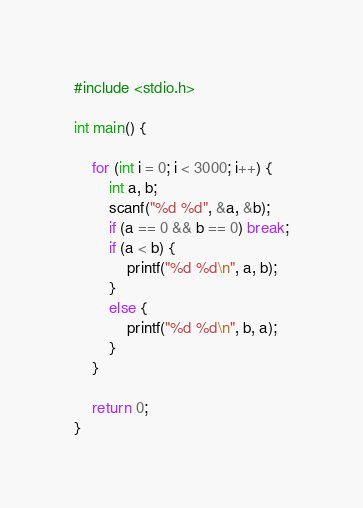Convert code to text. <code><loc_0><loc_0><loc_500><loc_500><_C_>#include <stdio.h>

int main() {

	for (int i = 0; i < 3000; i++) {
		int a, b;
		scanf("%d %d", &a, &b);
		if (a == 0 && b == 0) break;
		if (a < b) {
			printf("%d %d\n", a, b);
		}
		else {
			printf("%d %d\n", b, a);
		}
	}

	return 0;
}
</code> 